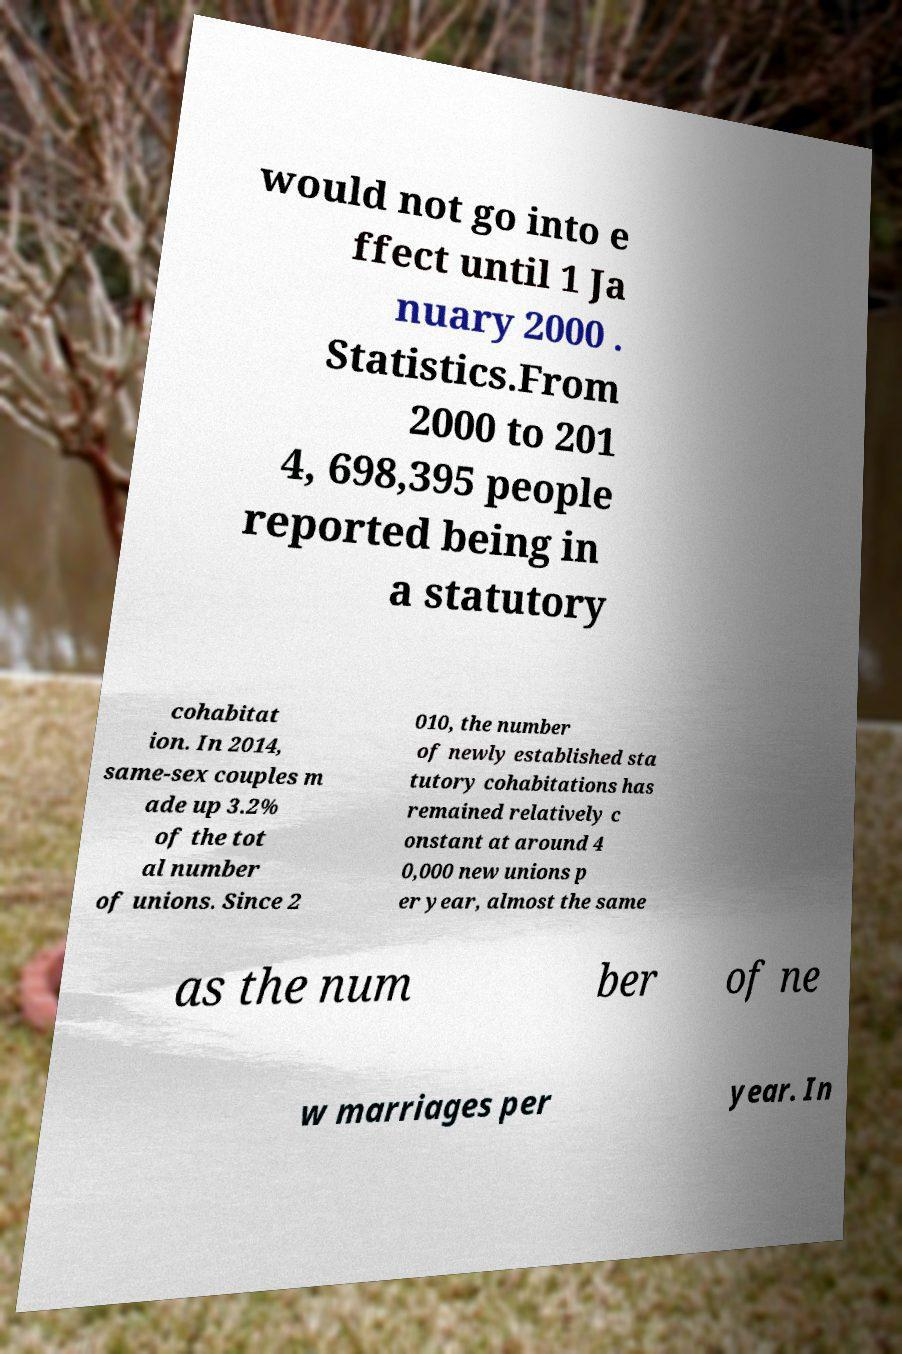Please identify and transcribe the text found in this image. would not go into e ffect until 1 Ja nuary 2000 . Statistics.From 2000 to 201 4, 698,395 people reported being in a statutory cohabitat ion. In 2014, same-sex couples m ade up 3.2% of the tot al number of unions. Since 2 010, the number of newly established sta tutory cohabitations has remained relatively c onstant at around 4 0,000 new unions p er year, almost the same as the num ber of ne w marriages per year. In 